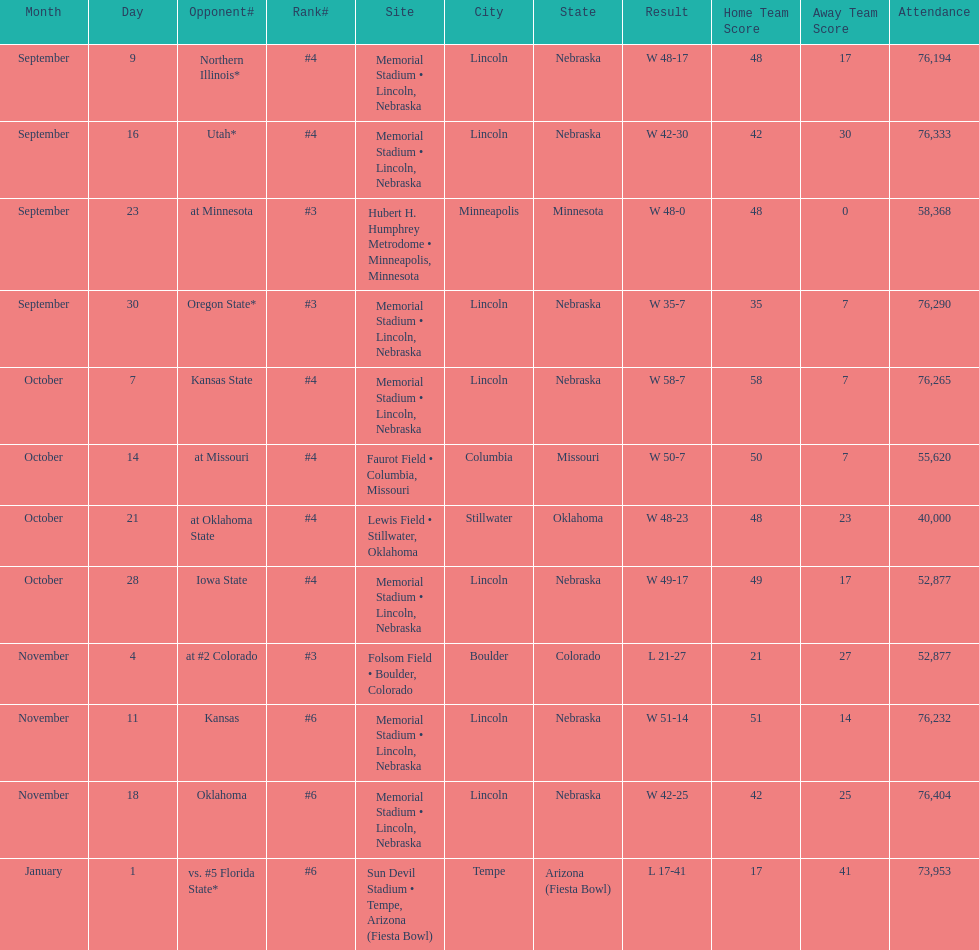How many games did they win by more than 7? 10. Could you help me parse every detail presented in this table? {'header': ['Month', 'Day', 'Opponent#', 'Rank#', 'Site', 'City', 'State', 'Result', 'Home Team Score', 'Away Team Score', 'Attendance'], 'rows': [['September', '9', 'Northern Illinois*', '#4', 'Memorial Stadium • Lincoln, Nebraska', 'Lincoln', 'Nebraska', 'W\xa048-17', '48', '17', '76,194'], ['September', '16', 'Utah*', '#4', 'Memorial Stadium • Lincoln, Nebraska', 'Lincoln', 'Nebraska', 'W\xa042-30', '42', '30', '76,333'], ['September', '23', 'at\xa0Minnesota', '#3', 'Hubert H. Humphrey Metrodome • Minneapolis, Minnesota', 'Minneapolis', 'Minnesota', 'W\xa048-0', '48', '0', '58,368'], ['September', '30', 'Oregon State*', '#3', 'Memorial Stadium • Lincoln, Nebraska', 'Lincoln', 'Nebraska', 'W\xa035-7', '35', '7', '76,290'], ['October', '7', 'Kansas State', '#4', 'Memorial Stadium • Lincoln, Nebraska', 'Lincoln', 'Nebraska', 'W\xa058-7', '58', '7', '76,265'], ['October', '14', 'at\xa0Missouri', '#4', 'Faurot Field • Columbia, Missouri', 'Columbia', 'Missouri', 'W\xa050-7', '50', '7', '55,620'], ['October', '21', 'at\xa0Oklahoma State', '#4', 'Lewis Field • Stillwater, Oklahoma', 'Stillwater', 'Oklahoma', 'W\xa048-23', '48', '23', '40,000'], ['October', '28', 'Iowa State', '#4', 'Memorial Stadium • Lincoln, Nebraska', 'Lincoln', 'Nebraska', 'W\xa049-17', '49', '17', '52,877'], ['November', '4', 'at\xa0#2\xa0Colorado', '#3', 'Folsom Field • Boulder, Colorado', 'Boulder', 'Colorado', 'L\xa021-27', '21', '27', '52,877'], ['November', '11', 'Kansas', '#6', 'Memorial Stadium • Lincoln, Nebraska', 'Lincoln', 'Nebraska', 'W\xa051-14', '51', '14', '76,232'], ['November', '18', 'Oklahoma', '#6', 'Memorial Stadium • Lincoln, Nebraska', 'Lincoln', 'Nebraska', 'W\xa042-25', '42', '25', '76,404'], ['January', '1', 'vs.\xa0#5\xa0Florida State*', '#6', 'Sun Devil Stadium • Tempe, Arizona (Fiesta Bowl)', 'Tempe', 'Arizona (Fiesta Bowl)', 'L\xa017-41', '17', '41', '73,953']]} 